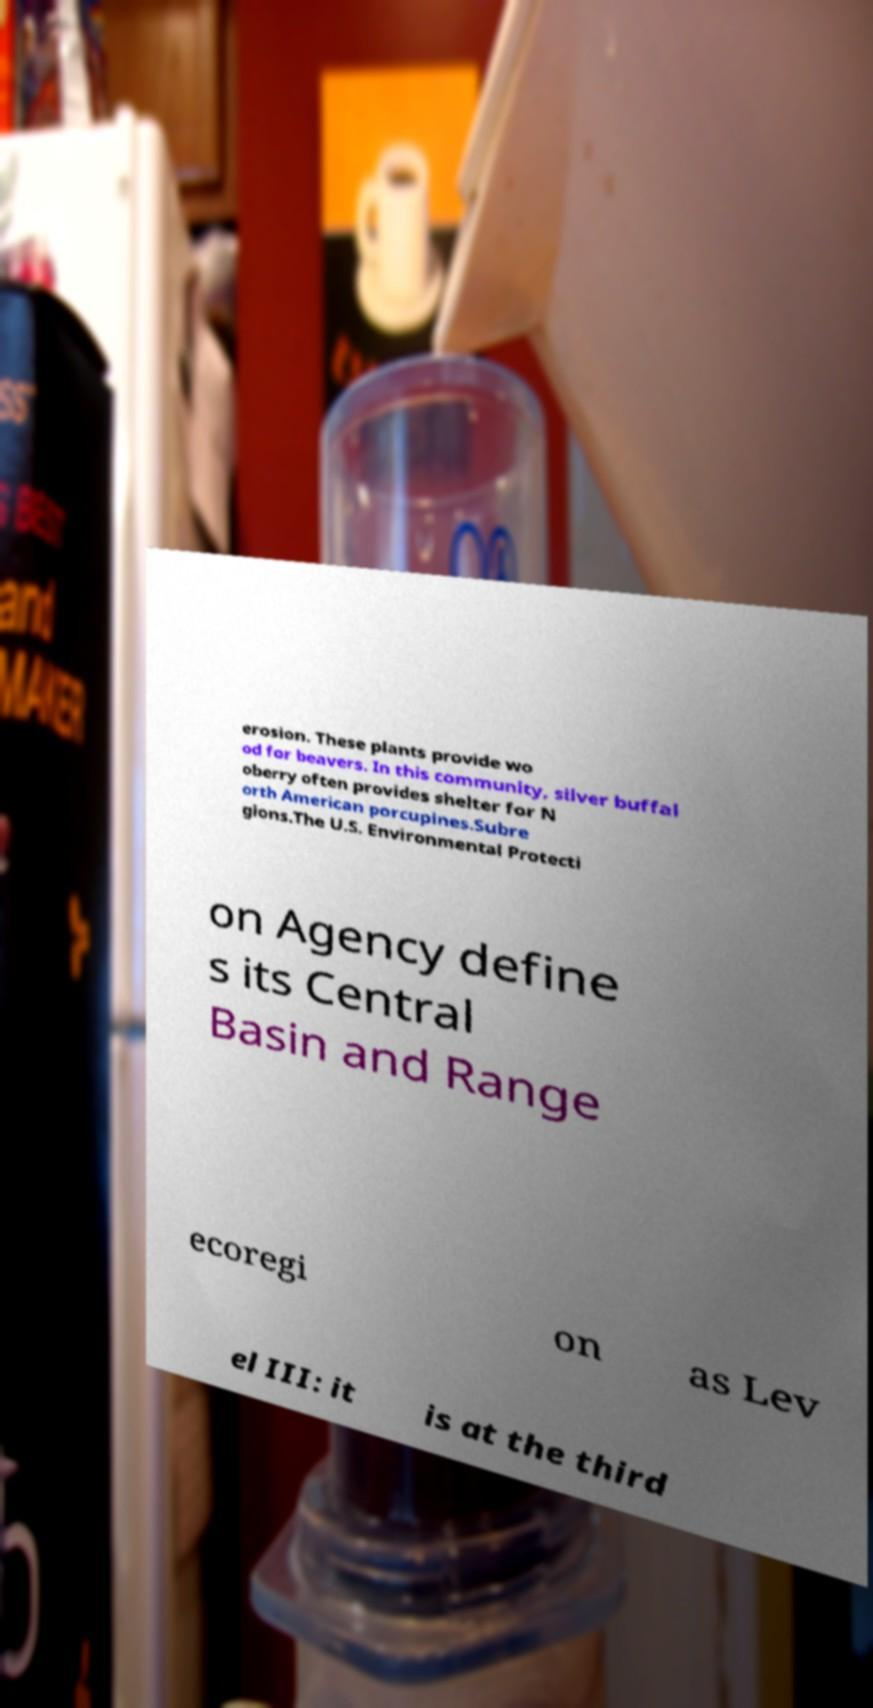For documentation purposes, I need the text within this image transcribed. Could you provide that? erosion. These plants provide wo od for beavers. In this community, silver buffal oberry often provides shelter for N orth American porcupines.Subre gions.The U.S. Environmental Protecti on Agency define s its Central Basin and Range ecoregi on as Lev el III: it is at the third 